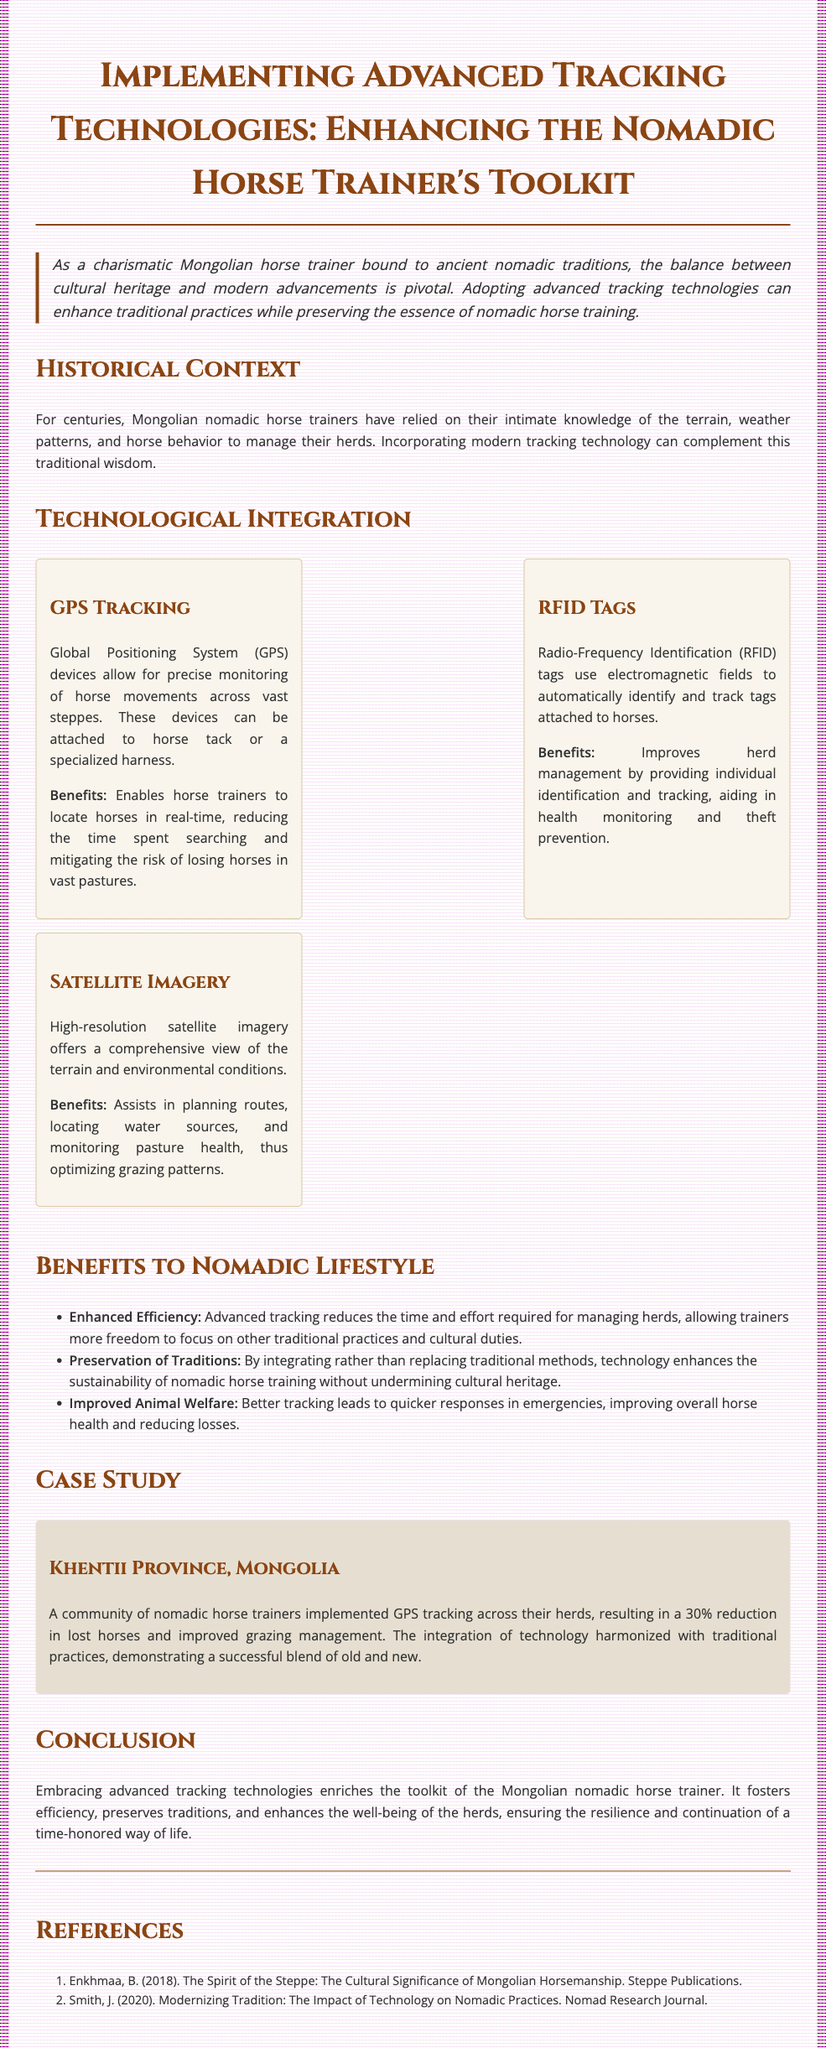What is the title of the document? The title is the main heading indicating the subject matter of the document.
Answer: Implementing Advanced Tracking Technologies: Enhancing the Nomadic Horse Trainer's Toolkit What ancient traditions are mentioned? The document discusses the ancient nomadic traditions of Mongolian horse trainers, highlighting their balance with modern advancements.
Answer: Nomadic traditions What are the benefits of GPS tracking mentioned? The document enumerates benefits associated with GPS tracking for horse trainers, which can be clearly found in that section.
Answer: Enables horse trainers to locate horses in real-time What reduction in lost horses was achieved in the case study? The case study section provides specific results regarding improvements seen among the community implementing GPS tracking.
Answer: 30% What type of technology is used for individual identification of horses? The document specifies which technology is utilized for tracking while identifying individual horses.
Answer: RFID tags How does advanced tracking improve animal welfare? The document explains how technology aids in quicker responses during equine emergencies, enhancing their health.
Answer: Better tracking leads to quicker responses in emergencies What does the introduction emphasize about technology and tradition? The introduction outlines the importance of balancing cultural heritage with modern advancements, establishing its theme.
Answer: Enhancing traditional practices What community is highlighted in the case study? The document points out a specific community where tracking technology was implemented successfully.
Answer: Khentii Province, Mongolia 